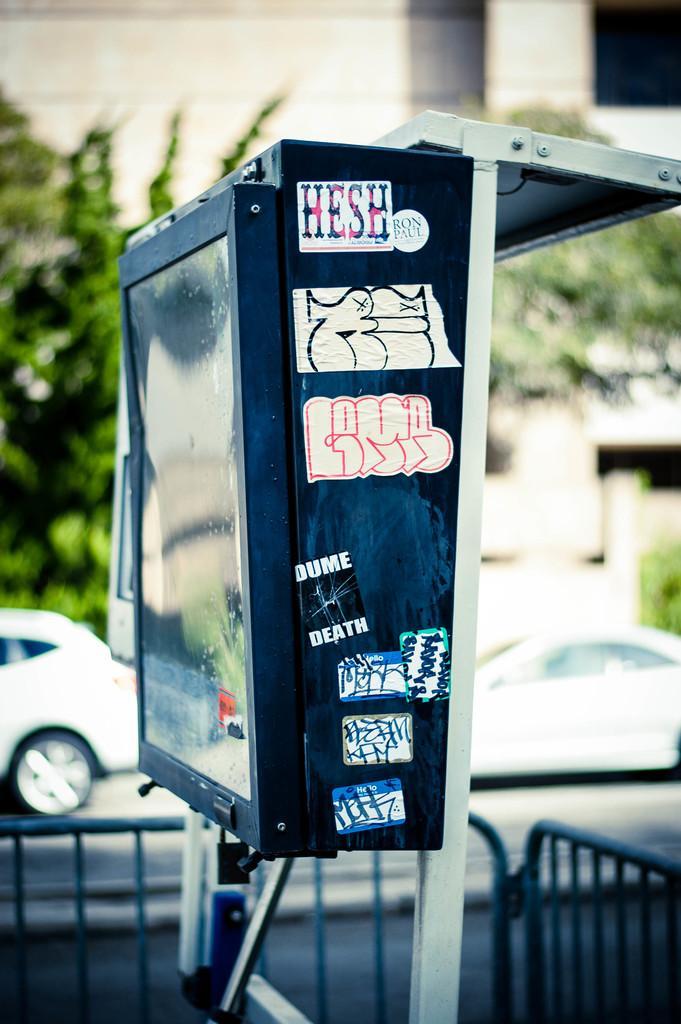Please provide a concise description of this image. Here we can see a box, fence, and cars on the road. In the background there are trees and a building. 